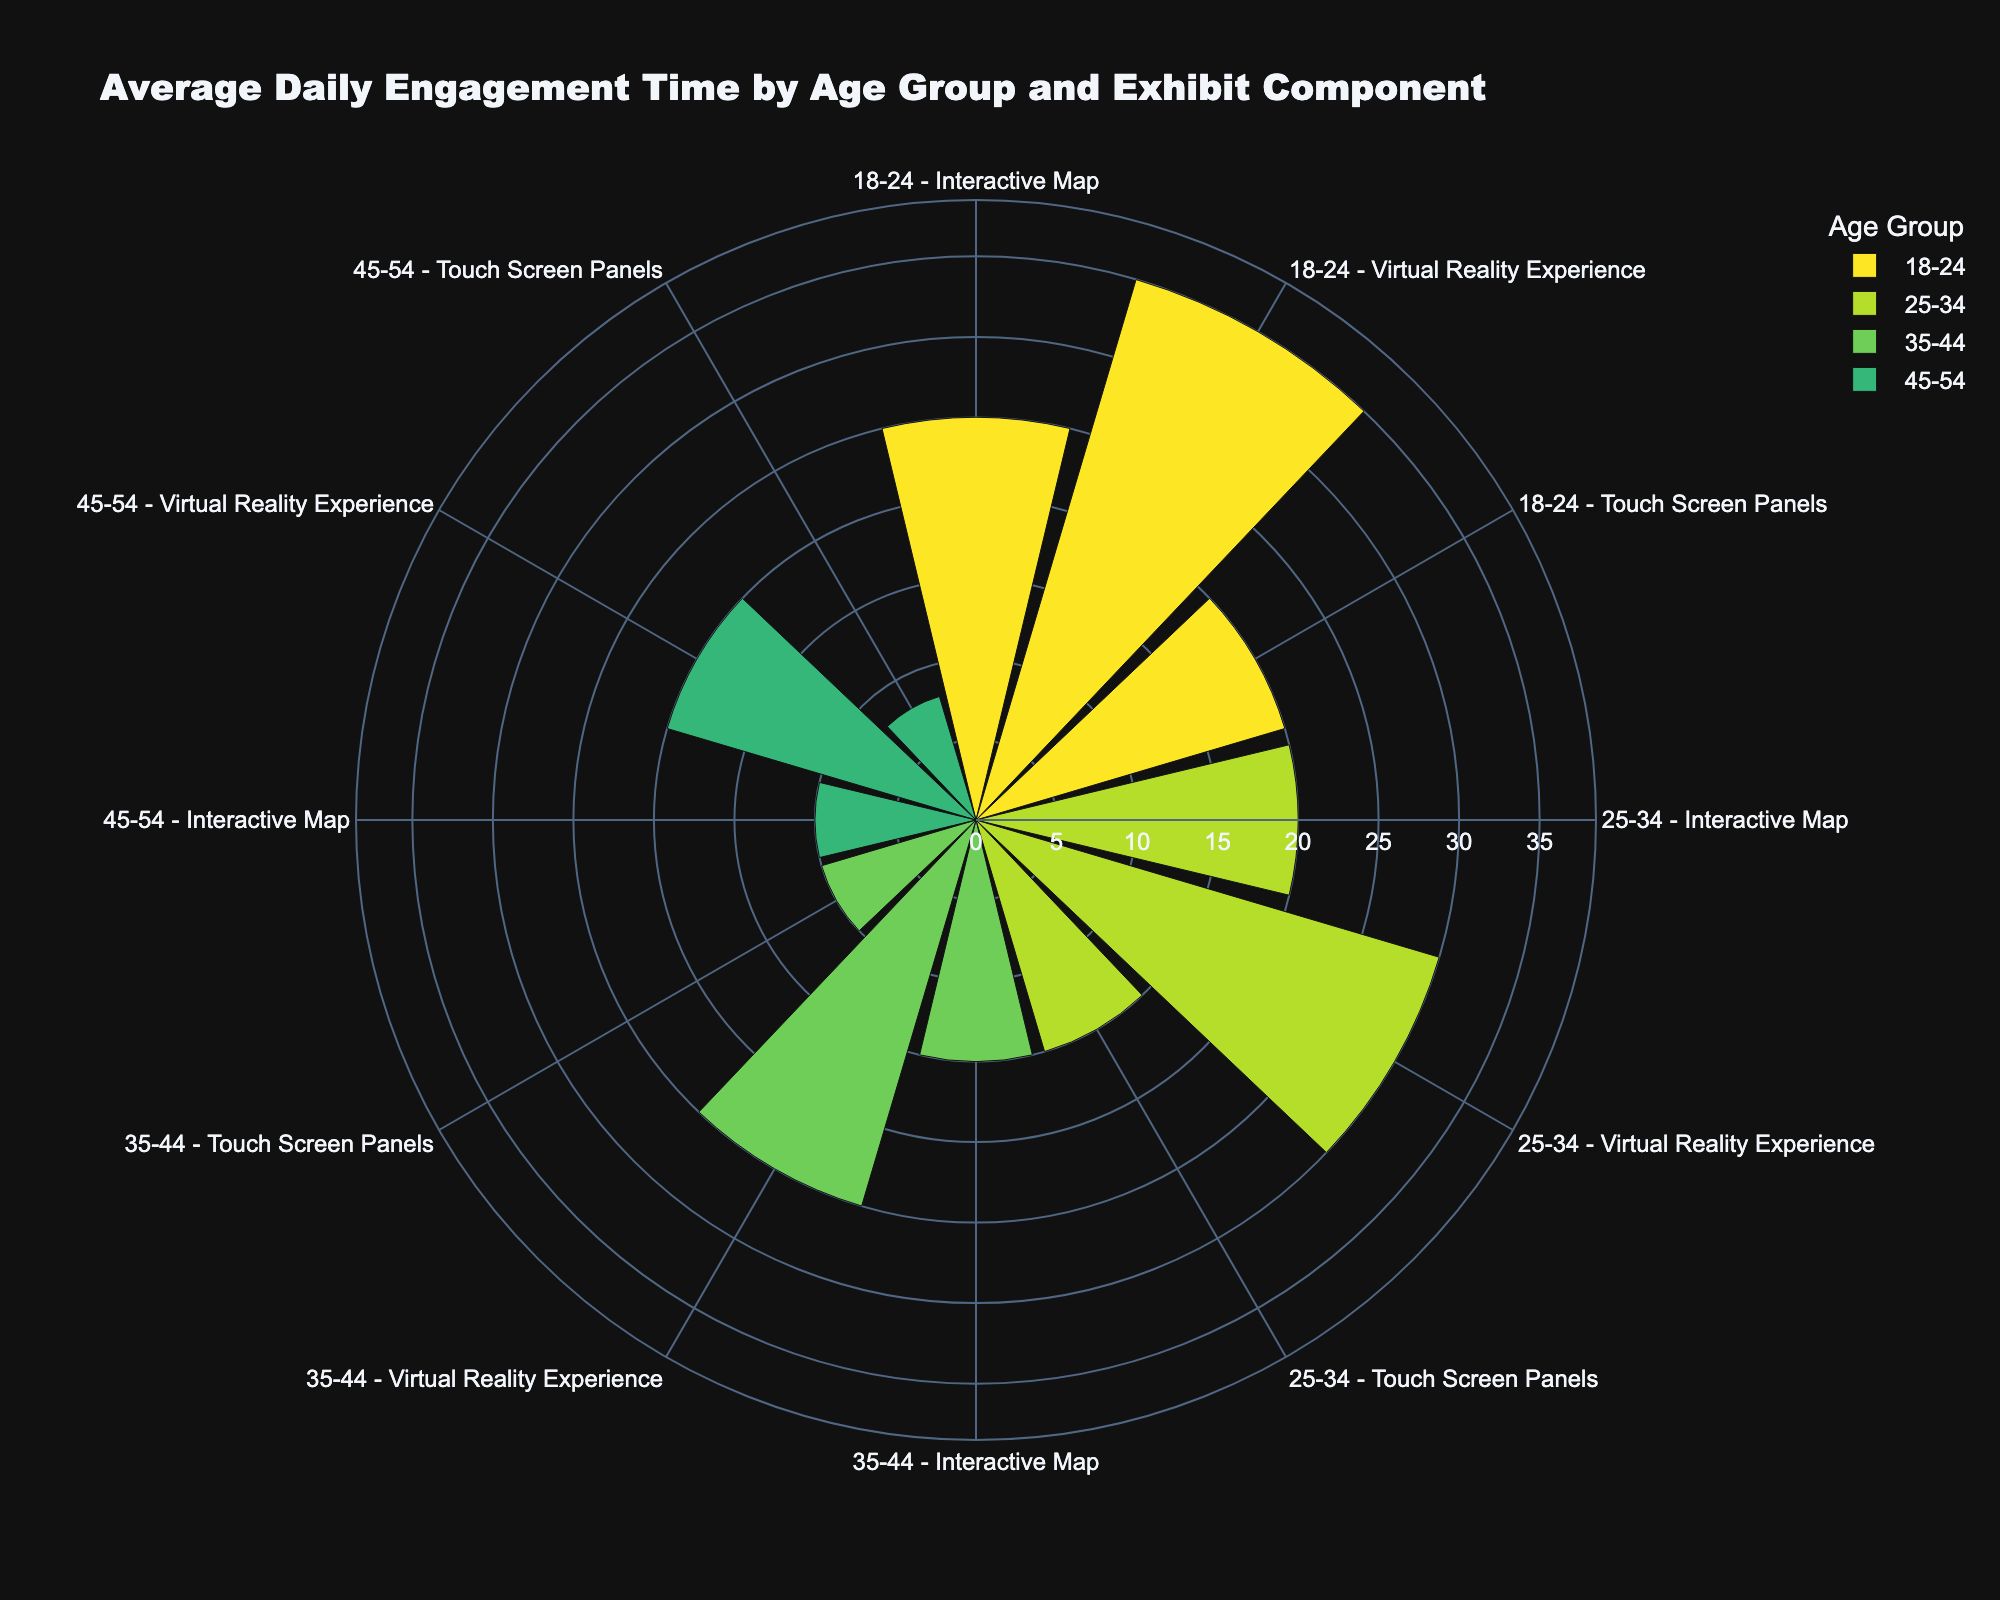How many age groups are displayed in the figure? By looking at the labeling and legend, it's clear there are four age groups represented: 18-24, 25-34, 35-44, and 45-54.
Answer: 4 Which exhibit component has the highest engagement time for the 18-24 age group? This can be found by locating the segments associated with the 18-24 age group and comparing their lengths. The "Virtual Reality Experience" for the 18-24 group is the longest.
Answer: Virtual Reality Experience What is the total average daily engagement time for the "Touch Screen Panels" across all age groups? Add the engagement times for "Touch Screen Panels" for all age groups: 20 (18-24) + 15 (25-34) + 10 (35-44) + 8 (45-54).
Answer: 53 Which age group spends the least time with "Interactive Map"? By comparing the lengths of the "Interactive Map" segments across all age groups, the 45-54 group has the shortest segment.
Answer: 45-54 What is the difference in engagement time with "Virtual Reality Experience" between the 25-34 and 45-54 age groups? Subtract the engagement time of the 45-54 group (20) from the 25-34 group (30) for the "Virtual Reality Experience".
Answer: 10 How does the engagement time with "Touch Screen Panels" compare between the 18-24 and 35-44 age groups? Compare the lengths of the "Touch Screen Panels" segments for the 18-24 and 35-44 age groups. The 18-24 group spends more time (20) than the 35-44 group (10).
Answer: More for 18-24 What's the average engagement time for all exhibit components for the 25-34 age group? Add the engagement times for all exhibit components for the 25-34 group: 20 (Map) + 30 (VR) + 15 (Touch Screen) and divide by 3.
Answer: 21.67 In which age group does the "Virtual Reality Experience" have the highest average daily engagement time? By comparing the lengths of the "Virtual Reality Experience" segments, the 18-24 group's segment is the longest.
Answer: 18-24 Are there any exhibit components where engagement time decreases consistently with increasing age groups? By examining each component, "Interactive Map" and "Touch Screen Panels" both show a consistent decrease as age increases.
Answer: Yes What's the total engagement time for the 35-44 age group across all components? Add the engagement times for the 35-44 group across all components: 15 (Map) + 25 (VR) + 10 (Touch Screen).
Answer: 50 